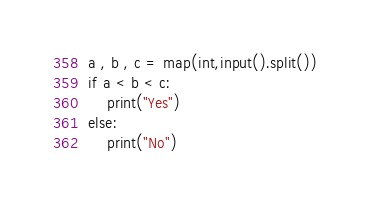Convert code to text. <code><loc_0><loc_0><loc_500><loc_500><_Python_>a , b , c = map(int,input().split())
if a < b < c:
    print("Yes")
else:
    print("No")
</code> 